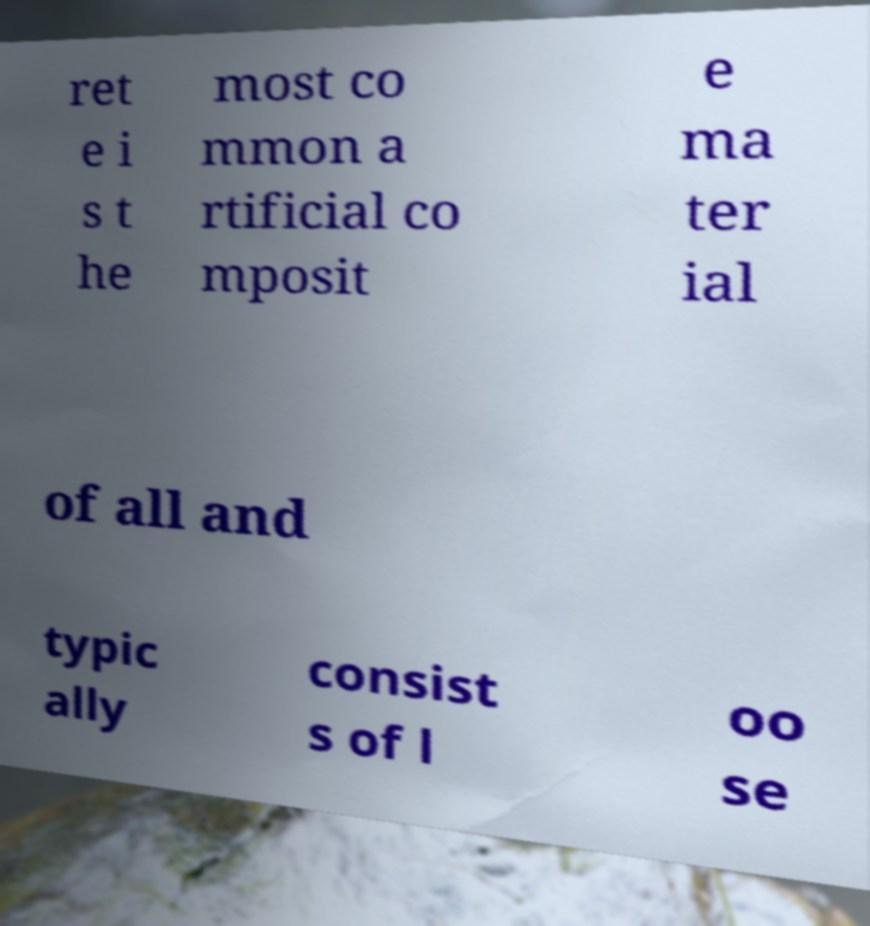Can you accurately transcribe the text from the provided image for me? ret e i s t he most co mmon a rtificial co mposit e ma ter ial of all and typic ally consist s of l oo se 